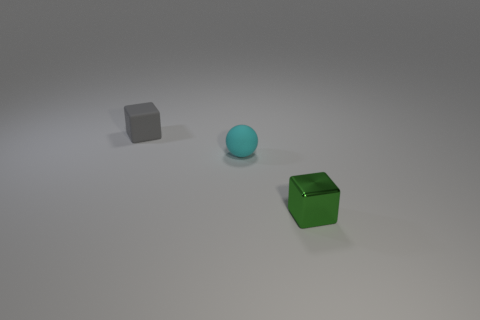Add 3 small spheres. How many objects exist? 6 Subtract all balls. How many objects are left? 2 Subtract all tiny shiny objects. Subtract all small shiny cylinders. How many objects are left? 2 Add 2 tiny blocks. How many tiny blocks are left? 4 Add 3 tiny green metallic things. How many tiny green metallic things exist? 4 Subtract 0 yellow cylinders. How many objects are left? 3 